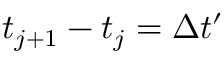Convert formula to latex. <formula><loc_0><loc_0><loc_500><loc_500>t _ { j + 1 } - t _ { j } = \Delta t ^ { \prime }</formula> 